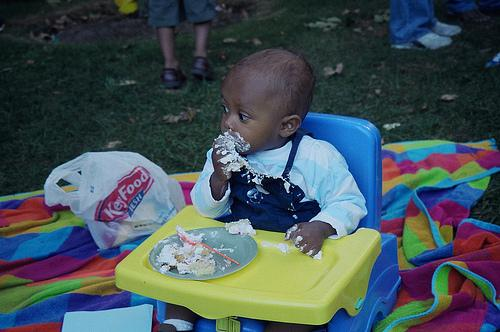Question: how many little boys are sitting?
Choices:
A. 1.
B. 12.
C. 13.
D. 5.
Answer with the letter. Answer: A Question: where is a boy sitting?
Choices:
A. In red chair.
B. In white chair.
C. In blue chair.
D. In brown chair.
Answer with the letter. Answer: C Question: who is eating cake?
Choices:
A. Little boy.
B. Little girl.
C. Toddler.
D. Baby.
Answer with the letter. Answer: A Question: what is blue?
Choices:
A. Girl's overalls.
B. Boy's overalls.
C. Man's overalls.
D. Woman's overalls.
Answer with the letter. Answer: B Question: why is cake on a plate?
Choices:
A. To be eaten.
B. For display.
C. To cool.
D. To be iced.
Answer with the letter. Answer: A Question: what is white?
Choices:
A. Cake.
B. The sheets on the bed.
C. The dog.
D. The bread.
Answer with the letter. Answer: A Question: what is green?
Choices:
A. The leaves.
B. Celery.
C. The Kool-Aid.
D. Grass.
Answer with the letter. Answer: D 